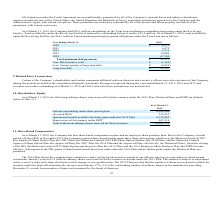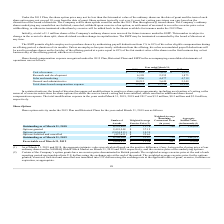According to Mimecast Limited's financial document, What was the Total share-based compensation expense in 2019? According to the financial document, $25,954. The relevant text states: "Total share-based compensation expense $ 25,954 $ 11,734 $ 10,294..." Also, What became effective upon the closing of the IPO? the Mimecast Limited 2015 Share Option and Incentive Plan (the 2015 Plan) and the 2015 Employee Share Purchase Plan (the ESPP). The document states: "he Historical Plans). Upon the closing of the IPO, the Mimecast Limited 2015 Share Option and Incentive Plan (the 2015 Plan) and the 2015 Employee Sha..." Also, How much was the total modification expense in the years ended March 31, 2019, 2018 and 2017 respectively? The document contains multiple relevant values: $3.2 million, $0.5 million, $3.0 million. From the document: "the years ended March 31, 2019, 2018 and 2017 was $3.2 million, $0.5 million and $3.0 million, respectively. ed March 31, 2019, 2018 and 2017 was $3.2..." Also, can you calculate: What is the change in Cost of revenue from Year Ending March 31, 2018 to 2019? Based on the calculation: 1,684-1,053, the result is 631. This is based on the information: "Cost of revenue $ 1,684 $ 1,053 $ 1,353 Cost of revenue $ 1,684 $ 1,053 $ 1,353..." The key data points involved are: 1,053, 1,684. Also, can you calculate: What is the change in Research and development expense from Year Ending March 31, 2018 to 2019? Based on the calculation: 6,199-2,555, the result is 3644. This is based on the information: "Research and development 6,199 2,555 1,873 Research and development 6,199 2,555 1,873..." The key data points involved are: 2,555, 6,199. Also, can you calculate: What is the change in Sales and marketing expense from Year Ending March 31, 2018 to 2019? Based on the calculation: 7,856-4,477, the result is 3379. This is based on the information: "Sales and marketing 7,856 4,477 4,719 Sales and marketing 7,856 4,477 4,719..." The key data points involved are: 4,477, 7,856. 